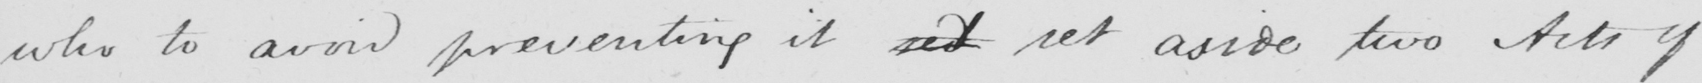Transcribe the text shown in this historical manuscript line. who to avoid preventing it sed set aside two Acts of 